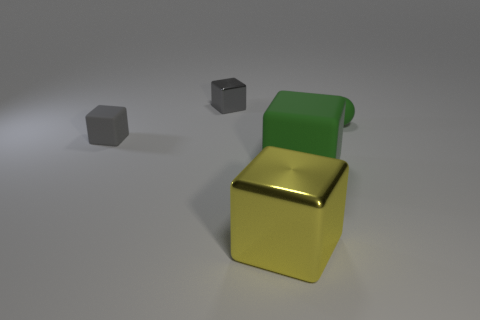Can you describe the spatial arrangement of the objects? Certainly, the composition includes a small matte sphere and cube placed to the left at differing distances, creating a sense of depth. The large glossy cube is situated prominently in the foreground, serving as a focal point while demonstrating a contrast in size and texture relative to the other objects. 